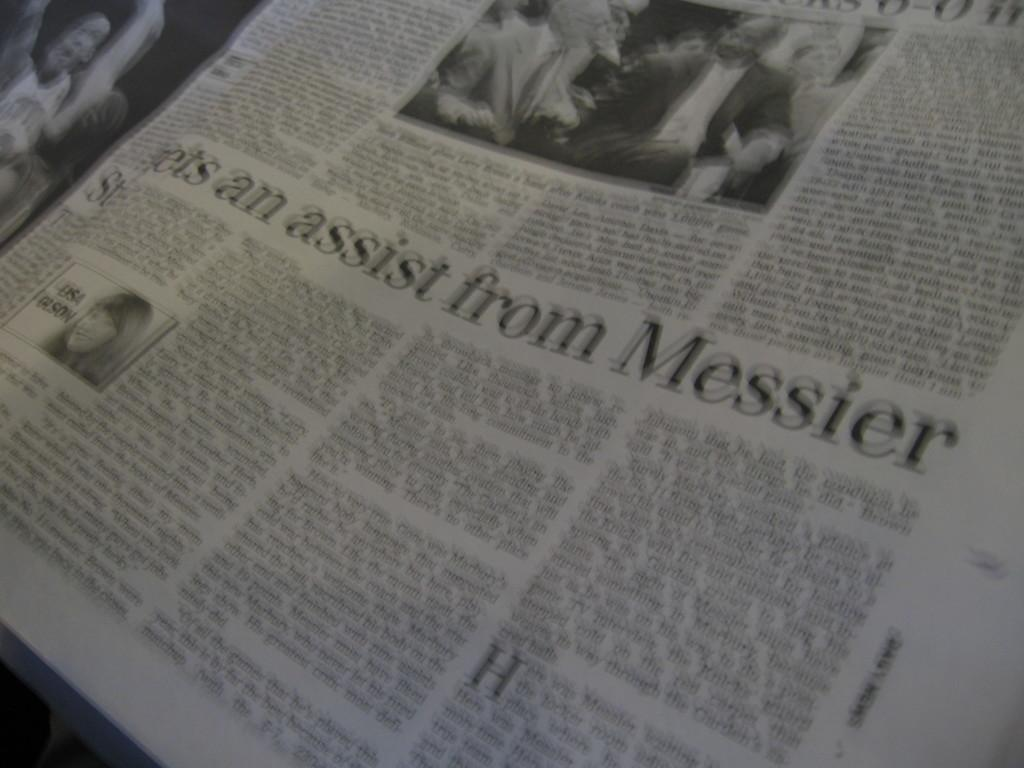What is the main object in the image? There is a newspaper in the image. What type of content can be found in the newspaper? The newspaper contains photos and text. Where is the nest located in the image? There is no nest present in the image. What type of wilderness can be seen through the window in the image? There is no window present in the image. 